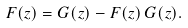<formula> <loc_0><loc_0><loc_500><loc_500>F ( z ) = G ( z ) - F ( z ) \, G ( z ) .</formula> 